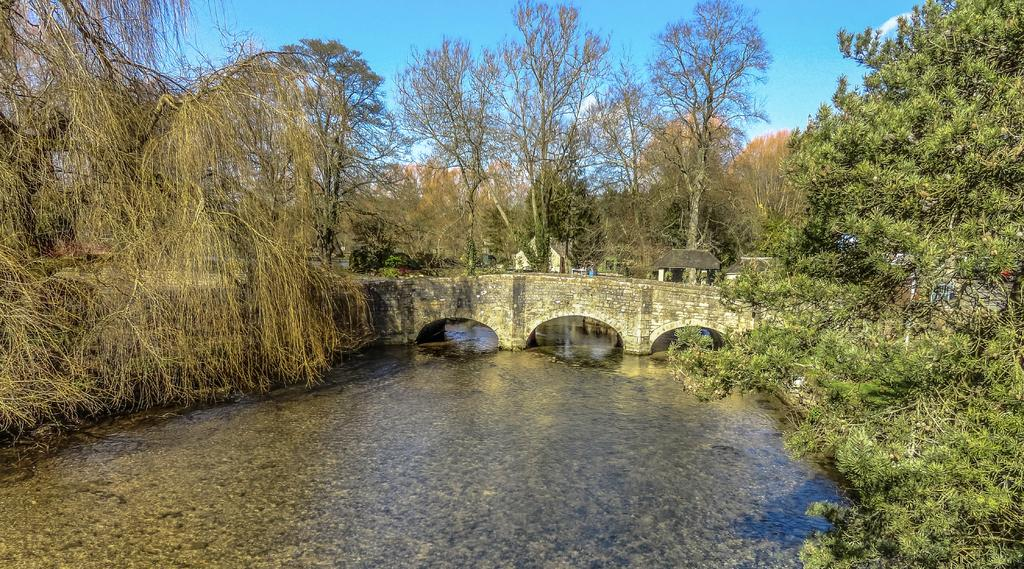What is at the bottom of the image? There is water at the bottom of the image. What structure can be seen in the middle of the image? There is a bridge in the middle of the image. What type of vegetation is visible in the background of the image? There are trees in the background of the image. What is visible at the top of the image? The sky is visible at the top of the image. What type of toothpaste is being used by the thought in the image? There is no thought or toothpaste present in the image. Can you describe the partner of the bridge in the image? There is no partner mentioned or depicted for the bridge in the image. 